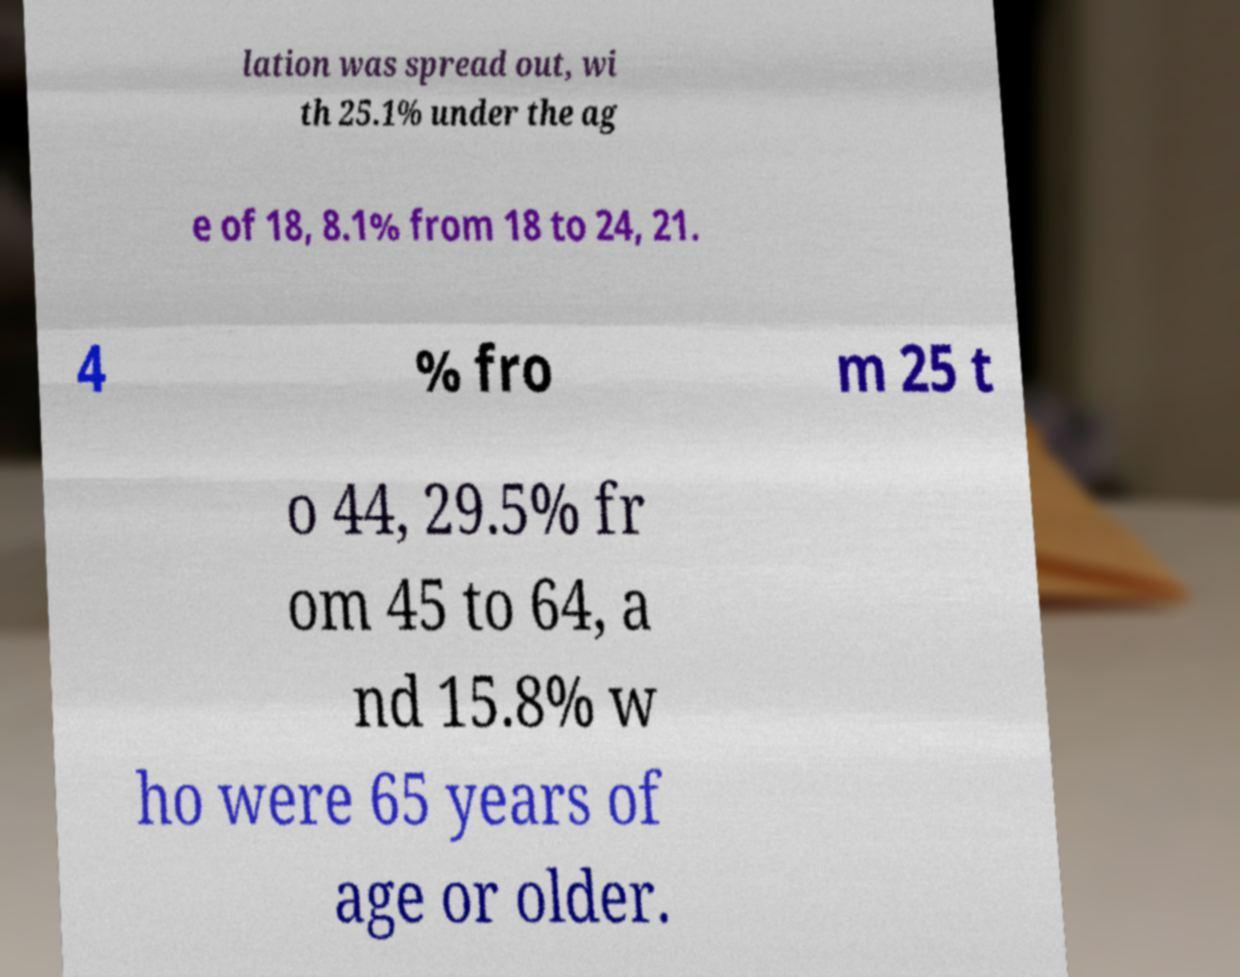I need the written content from this picture converted into text. Can you do that? lation was spread out, wi th 25.1% under the ag e of 18, 8.1% from 18 to 24, 21. 4 % fro m 25 t o 44, 29.5% fr om 45 to 64, a nd 15.8% w ho were 65 years of age or older. 